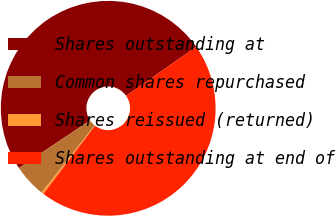Convert chart. <chart><loc_0><loc_0><loc_500><loc_500><pie_chart><fcel>Shares outstanding at<fcel>Common shares repurchased<fcel>Shares reissued (returned)<fcel>Shares outstanding at end of<nl><fcel>49.67%<fcel>4.98%<fcel>0.33%<fcel>45.02%<nl></chart> 